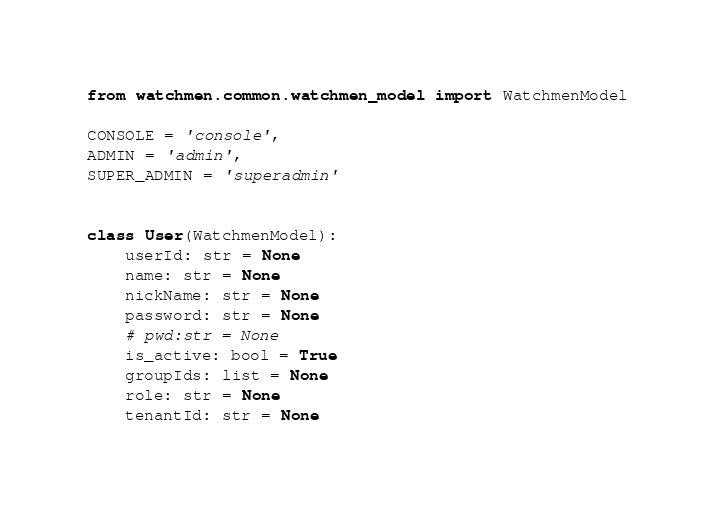Convert code to text. <code><loc_0><loc_0><loc_500><loc_500><_Python_>from watchmen.common.watchmen_model import WatchmenModel

CONSOLE = 'console',
ADMIN = 'admin',
SUPER_ADMIN = 'superadmin'


class User(WatchmenModel):
    userId: str = None
    name: str = None
    nickName: str = None
    password: str = None
    # pwd:str = None
    is_active: bool = True
    groupIds: list = None
    role: str = None
    tenantId: str = None
</code> 